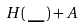Convert formula to latex. <formula><loc_0><loc_0><loc_500><loc_500>H ( \, \_ \, ) + A</formula> 